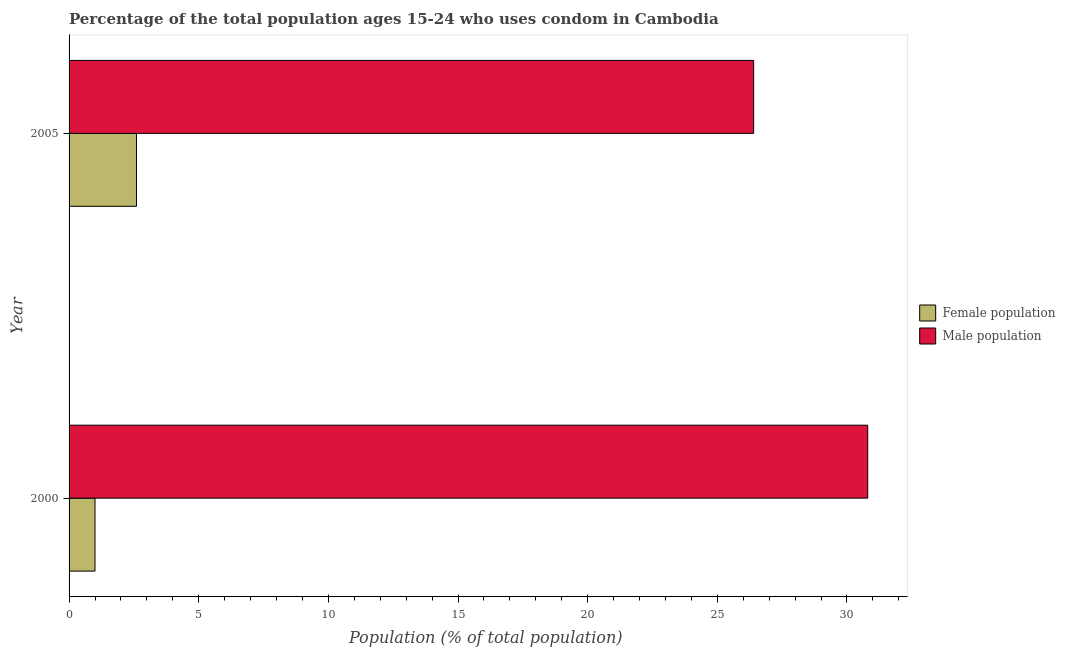Are the number of bars per tick equal to the number of legend labels?
Give a very brief answer. Yes. Are the number of bars on each tick of the Y-axis equal?
Your answer should be very brief. Yes. How many bars are there on the 1st tick from the top?
Offer a terse response. 2. In how many cases, is the number of bars for a given year not equal to the number of legend labels?
Provide a short and direct response. 0. Across all years, what is the minimum male population?
Your response must be concise. 26.4. What is the total male population in the graph?
Your response must be concise. 57.2. What is the difference between the female population in 2000 and that in 2005?
Offer a terse response. -1.6. What is the difference between the female population in 2000 and the male population in 2005?
Your answer should be very brief. -25.4. What is the average female population per year?
Offer a terse response. 1.8. In the year 2000, what is the difference between the male population and female population?
Make the answer very short. 29.8. What is the ratio of the male population in 2000 to that in 2005?
Provide a succinct answer. 1.17. What does the 1st bar from the top in 2005 represents?
Provide a short and direct response. Male population. What does the 1st bar from the bottom in 2000 represents?
Provide a succinct answer. Female population. Are all the bars in the graph horizontal?
Make the answer very short. Yes. What is the difference between two consecutive major ticks on the X-axis?
Provide a succinct answer. 5. Does the graph contain any zero values?
Your response must be concise. No. Does the graph contain grids?
Your answer should be compact. No. What is the title of the graph?
Make the answer very short. Percentage of the total population ages 15-24 who uses condom in Cambodia. What is the label or title of the X-axis?
Give a very brief answer. Population (% of total population) . What is the label or title of the Y-axis?
Your answer should be very brief. Year. What is the Population (% of total population)  in Male population in 2000?
Offer a terse response. 30.8. What is the Population (% of total population)  of Male population in 2005?
Offer a very short reply. 26.4. Across all years, what is the maximum Population (% of total population)  in Female population?
Provide a succinct answer. 2.6. Across all years, what is the maximum Population (% of total population)  of Male population?
Offer a very short reply. 30.8. Across all years, what is the minimum Population (% of total population)  of Male population?
Your response must be concise. 26.4. What is the total Population (% of total population)  in Male population in the graph?
Offer a very short reply. 57.2. What is the difference between the Population (% of total population)  in Female population in 2000 and that in 2005?
Your answer should be compact. -1.6. What is the difference between the Population (% of total population)  in Male population in 2000 and that in 2005?
Offer a terse response. 4.4. What is the difference between the Population (% of total population)  of Female population in 2000 and the Population (% of total population)  of Male population in 2005?
Provide a succinct answer. -25.4. What is the average Population (% of total population)  of Male population per year?
Ensure brevity in your answer.  28.6. In the year 2000, what is the difference between the Population (% of total population)  in Female population and Population (% of total population)  in Male population?
Offer a very short reply. -29.8. In the year 2005, what is the difference between the Population (% of total population)  of Female population and Population (% of total population)  of Male population?
Give a very brief answer. -23.8. What is the ratio of the Population (% of total population)  of Female population in 2000 to that in 2005?
Ensure brevity in your answer.  0.38. What is the ratio of the Population (% of total population)  of Male population in 2000 to that in 2005?
Keep it short and to the point. 1.17. What is the difference between the highest and the second highest Population (% of total population)  in Female population?
Give a very brief answer. 1.6. What is the difference between the highest and the second highest Population (% of total population)  of Male population?
Keep it short and to the point. 4.4. What is the difference between the highest and the lowest Population (% of total population)  of Female population?
Provide a succinct answer. 1.6. What is the difference between the highest and the lowest Population (% of total population)  in Male population?
Offer a very short reply. 4.4. 